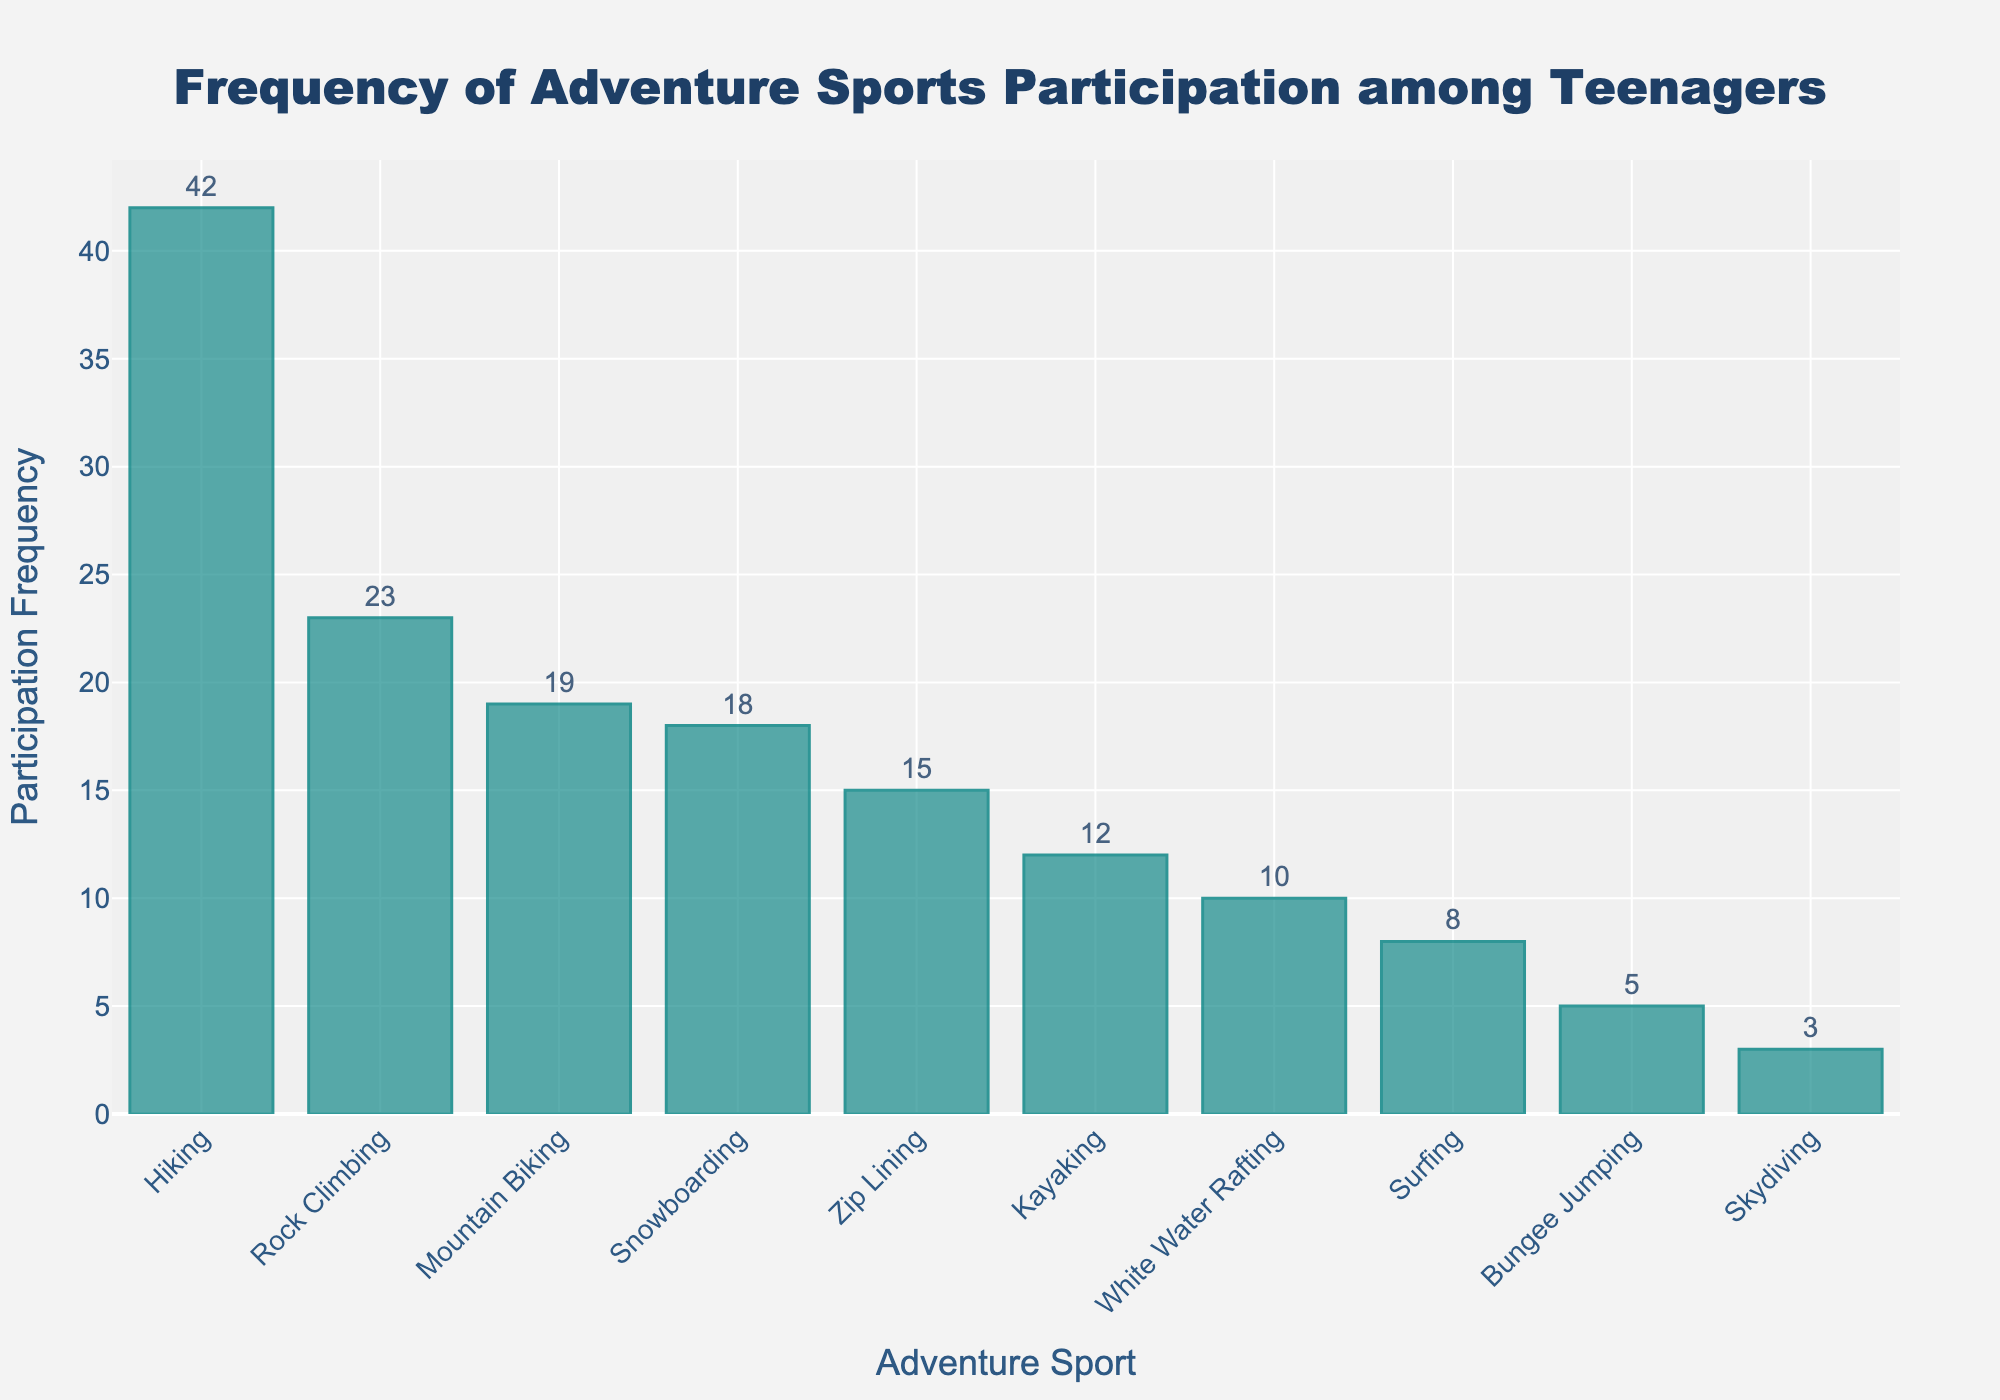How many teenagers participated in Snowboarding? To find the number of teenagers who participated in Snowboarding, refer to the corresponding bar on the x-axis. The height of the bar (y-value) shows the participation frequency.
Answer: 18 Which adventure sport has the highest participation frequency among teenagers? To determine the sport with the highest participation, look for the tallest bar on the histogram. The label on the x-axis of this bar indicates the sport.
Answer: Hiking What is the total participation frequency of Rock Climbing and Kayaking? Find the bar heights (y-values) for both Rock Climbing and Kayaking. Rock Climbing has 23 and Kayaking has 12. Adding these together gives the total participation frequency.
Answer: 35 Which adventure sport has a lower participation frequency, White Water Rafting or Surfing? Compare the heights of the bars labeled White Water Rafting and Surfing. Surfing has a participation frequency of 8, while White Water Rafting has 10. Surfing is lower.
Answer: Surfing How many adventure sports have a participation frequency higher than 20? Count the number of bars with heights greater than 20. These are Rock Climbing (23) and Hiking (42), which total 2 sports.
Answer: 2 What is the average participation frequency of Bungee Jumping, Skydiving, and Zip Lining? Find the participation frequencies of Bungee Jumping (5), Skydiving (3), and Zip Lining (15), then add them together (5 + 3 + 15 = 23) and divide by 3 to get the average.
Answer: 7.67 Is the participation in Mountain Biking greater than in Zip Lining? Compare the heights of the bars for Mountain Biking and Zip Lining. Mountain Biking has 19, while Zip Lining has 15. Therefore, Mountain Biking is greater.
Answer: Yes What is the combined participation frequency of sports with less than 10 participants? Identify the sports with frequencies less than 10: Surfing (8), Skydiving (3), and Bungee Jumping (5). Sum these frequencies (8 + 3 + 5 = 16).
Answer: 16 